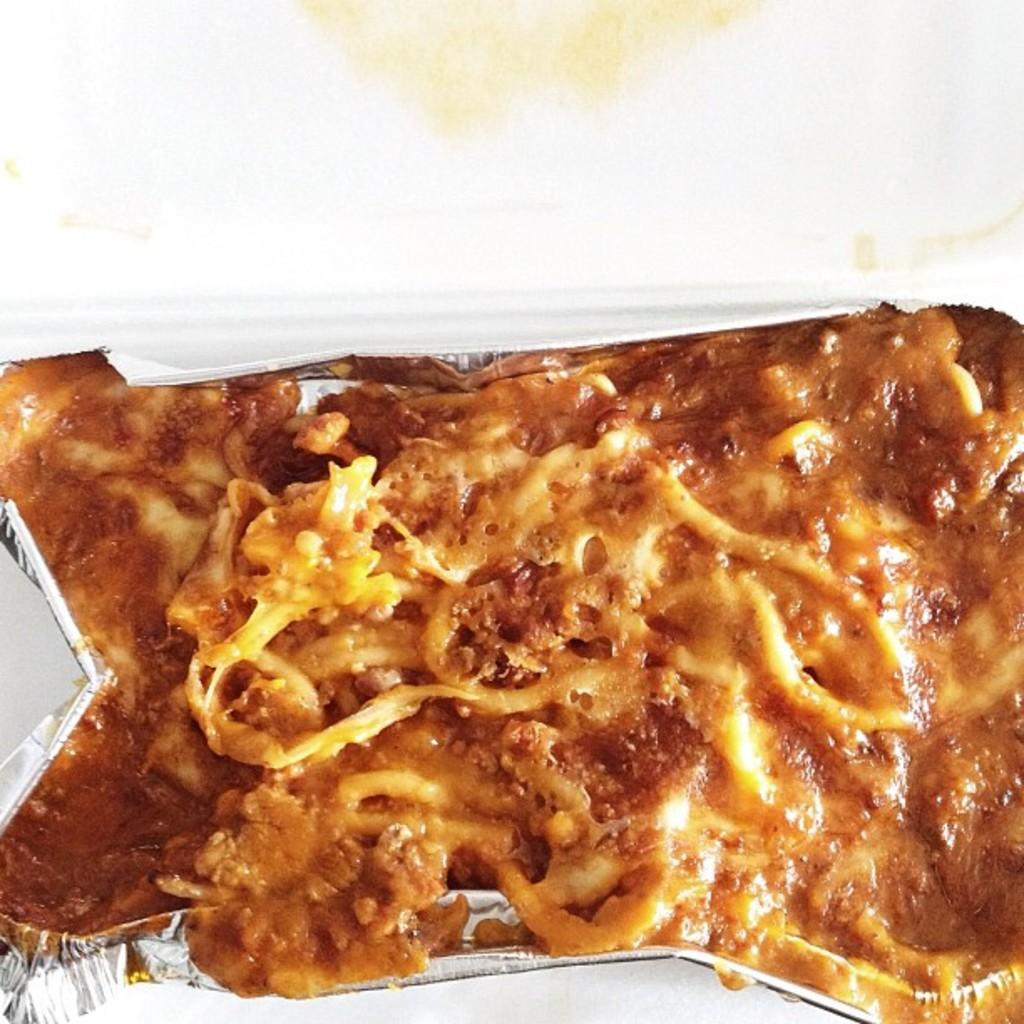What type of food is visible in the image? The image contains food, but the specific type of food is not mentioned in the facts. How is the food contained in the image? The food is in an aluminium foil container. What color is the background of the image? The background of the image is white. What direction is the needle pointing during the meeting in the image? There is no meeting or needle present in the image. 